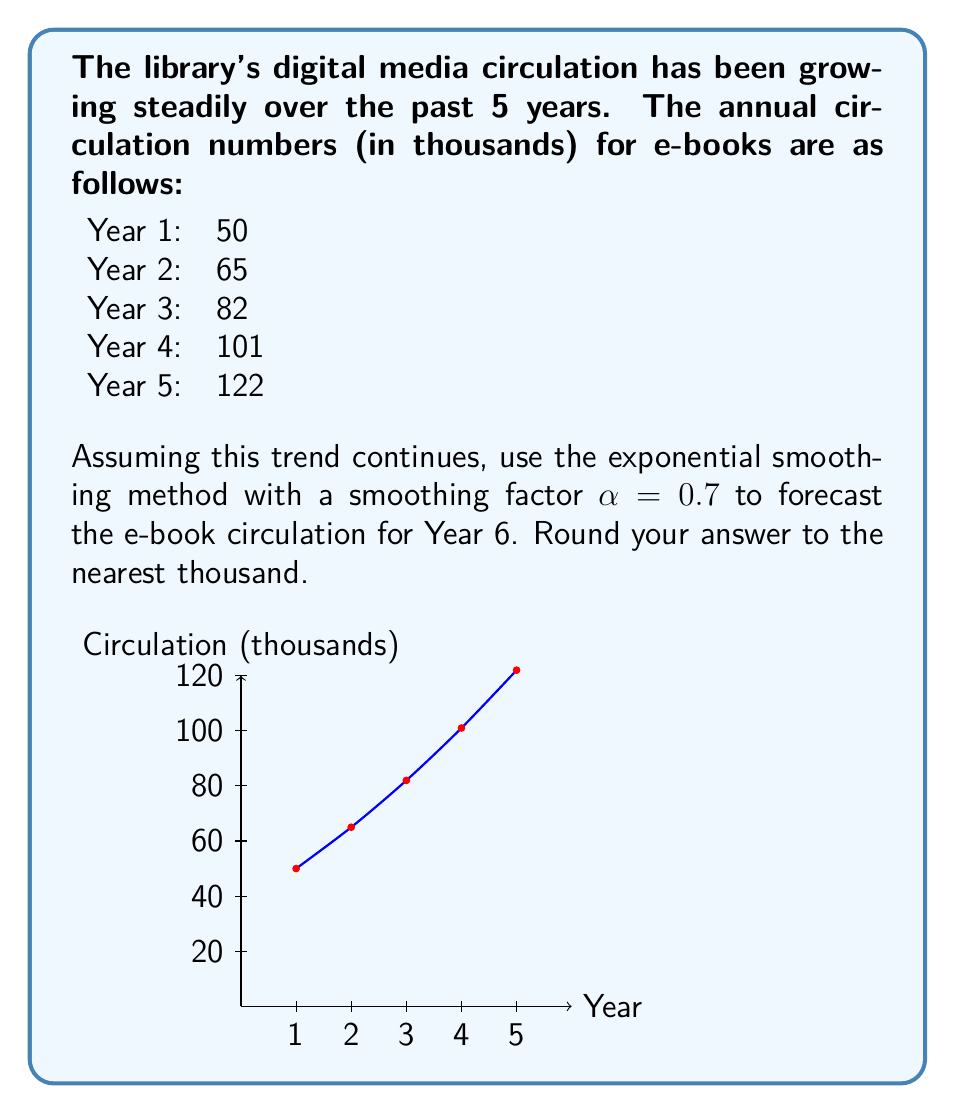Can you solve this math problem? To forecast using exponential smoothing, we'll use the formula:

$$F_{t+1} = \alpha Y_t + (1-\alpha)F_t$$

Where:
$F_{t+1}$ is the forecast for the next period
$\alpha$ is the smoothing factor (0.7 in this case)
$Y_t$ is the actual value for the current period
$F_t$ is the forecast for the current period

Step 1: Initialize the forecast
We'll use the first actual value as our initial forecast:
$F_1 = 50$

Step 2: Calculate forecasts for years 2-5
For Year 2: $F_2 = 0.7(50) + 0.3(50) = 50$
For Year 3: $F_3 = 0.7(65) + 0.3(50) = 60.5$
For Year 4: $F_4 = 0.7(82) + 0.3(60.5) = 75.55$
For Year 5: $F_5 = 0.7(101) + 0.3(75.55) = 93.665$

Step 3: Calculate the forecast for Year 6
$F_6 = 0.7(122) + 0.3(93.665) = 113.0995$

Step 4: Round to the nearest thousand
113.0995 thousand ≈ 113 thousand
Answer: 113 thousand 